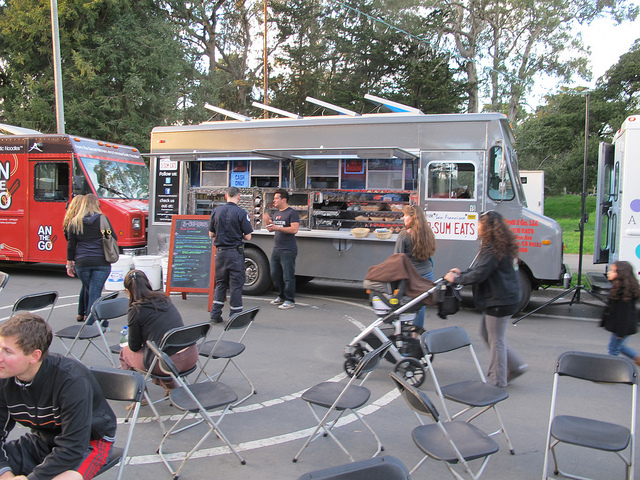What type of business is being conducted from the vehicle in the image? The vehicle in the image is a food truck, which is a popular type of mobile eatery where food is prepared and sold to customers often at outdoor locations. 